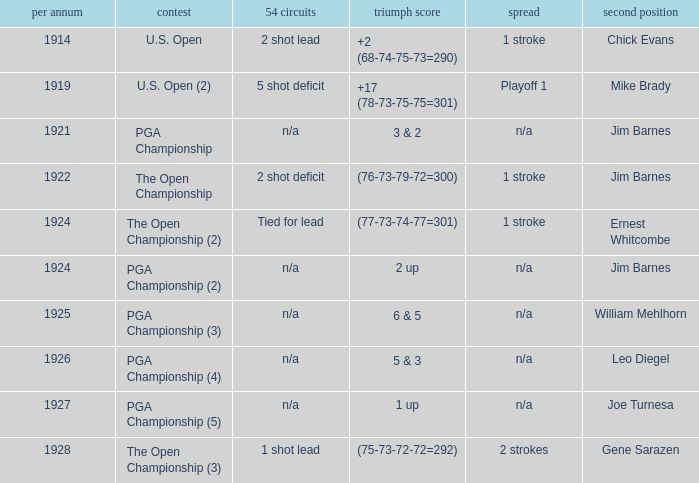WHAT WAS THE YEAR WHEN THE RUNNER-UP WAS WILLIAM MEHLHORN? 1925.0. 